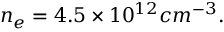Convert formula to latex. <formula><loc_0><loc_0><loc_500><loc_500>n _ { e } = 4 . 5 \times 1 0 ^ { 1 2 } c m ^ { - 3 } .</formula> 